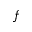Convert formula to latex. <formula><loc_0><loc_0><loc_500><loc_500>f</formula> 